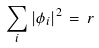<formula> <loc_0><loc_0><loc_500><loc_500>\sum _ { i } | \phi _ { i } | ^ { 2 } \, = \, r</formula> 